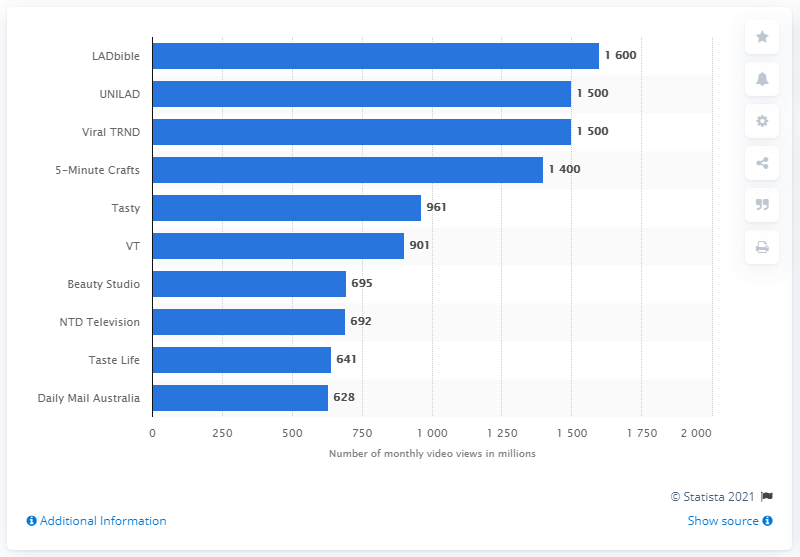Draw attention to some important aspects in this diagram. In March 2019, LADbible received approximately 1,600 video views. In March 2019, UNILAD was the second most watched video publisher on Facebook. 